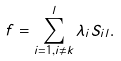<formula> <loc_0><loc_0><loc_500><loc_500>f = \sum _ { i = 1 , i \ne k } ^ { l } \lambda _ { i } S _ { i l } .</formula> 